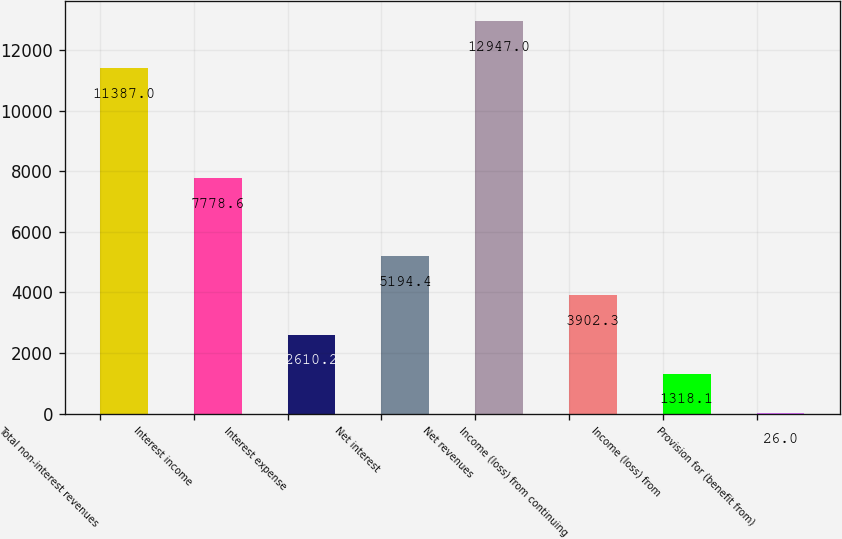Convert chart to OTSL. <chart><loc_0><loc_0><loc_500><loc_500><bar_chart><fcel>Total non-interest revenues<fcel>Interest income<fcel>Interest expense<fcel>Net interest<fcel>Net revenues<fcel>Income (loss) from continuing<fcel>Income (loss) from<fcel>Provision for (benefit from)<nl><fcel>11387<fcel>7778.6<fcel>2610.2<fcel>5194.4<fcel>12947<fcel>3902.3<fcel>1318.1<fcel>26<nl></chart> 